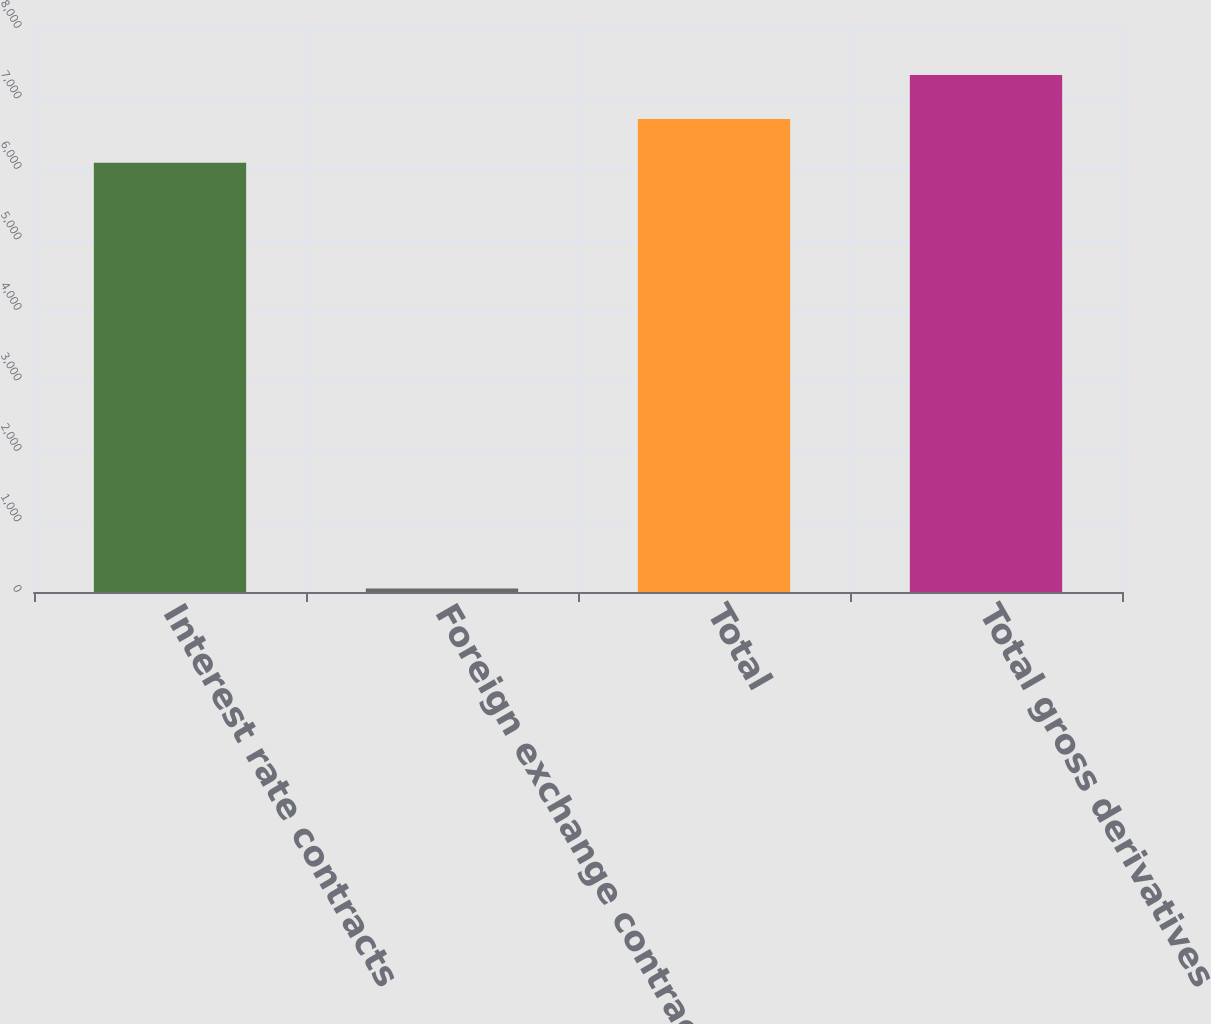Convert chart. <chart><loc_0><loc_0><loc_500><loc_500><bar_chart><fcel>Interest rate contracts<fcel>Foreign exchange contracts<fcel>Total<fcel>Total gross derivatives<nl><fcel>6087<fcel>48<fcel>6710.6<fcel>7334.2<nl></chart> 